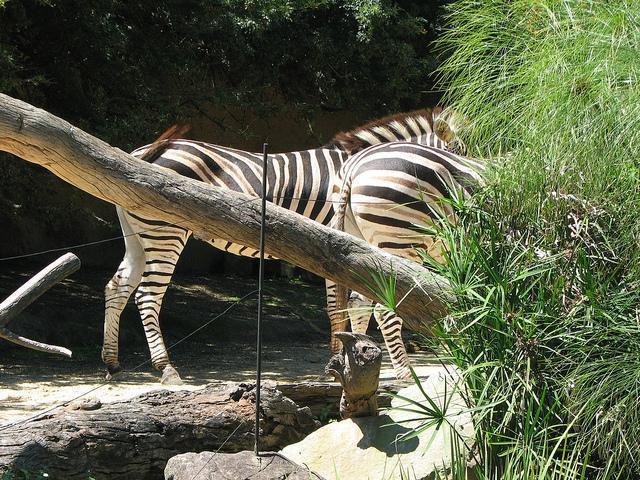How many animals are shown?
Give a very brief answer. 2. How many zebras are in the picture?
Give a very brief answer. 2. 